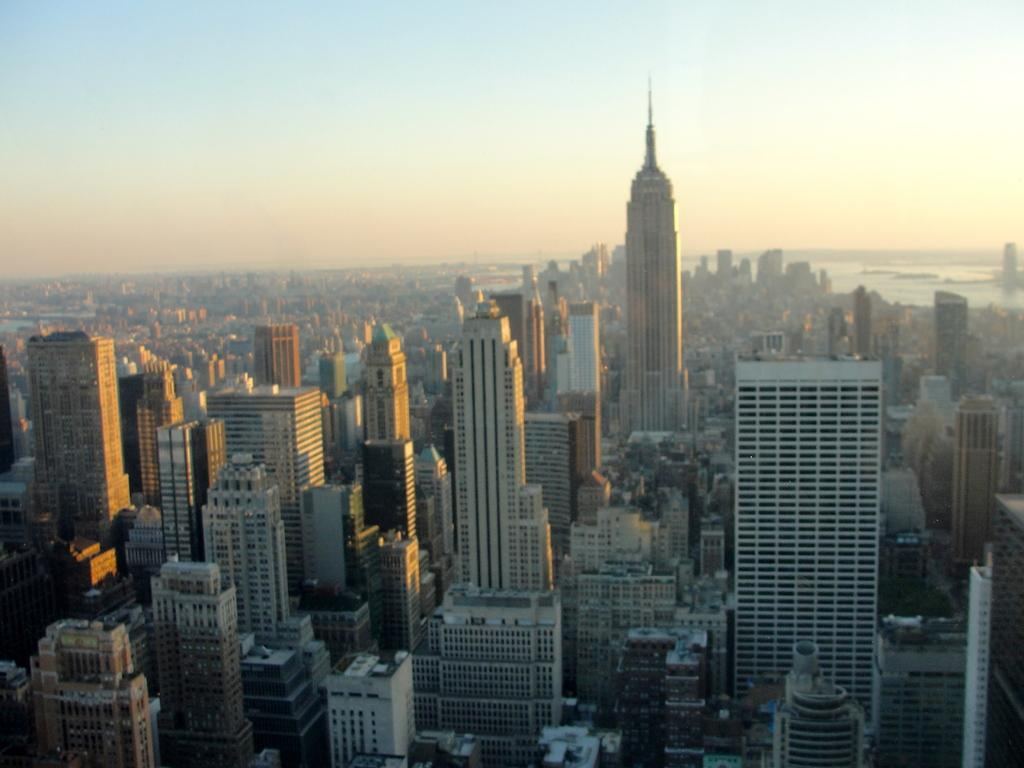What structures can be seen in the image? There are buildings in the image. What natural element is visible in the background of the image? There is water visible in the background of the image. What else can be seen in the background of the image? The sky is visible in the background of the image. How many birds can be seen using the hook in the image? There are no birds or hooks present in the image. 